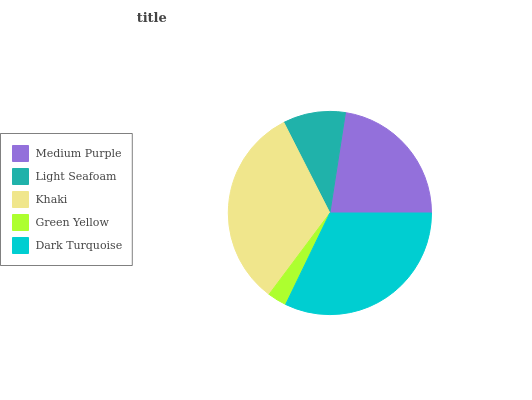Is Green Yellow the minimum?
Answer yes or no. Yes. Is Khaki the maximum?
Answer yes or no. Yes. Is Light Seafoam the minimum?
Answer yes or no. No. Is Light Seafoam the maximum?
Answer yes or no. No. Is Medium Purple greater than Light Seafoam?
Answer yes or no. Yes. Is Light Seafoam less than Medium Purple?
Answer yes or no. Yes. Is Light Seafoam greater than Medium Purple?
Answer yes or no. No. Is Medium Purple less than Light Seafoam?
Answer yes or no. No. Is Medium Purple the high median?
Answer yes or no. Yes. Is Medium Purple the low median?
Answer yes or no. Yes. Is Light Seafoam the high median?
Answer yes or no. No. Is Green Yellow the low median?
Answer yes or no. No. 